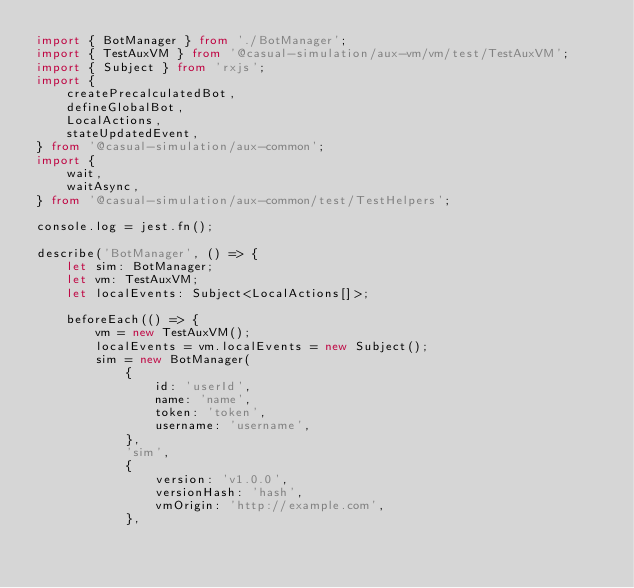Convert code to text. <code><loc_0><loc_0><loc_500><loc_500><_TypeScript_>import { BotManager } from './BotManager';
import { TestAuxVM } from '@casual-simulation/aux-vm/vm/test/TestAuxVM';
import { Subject } from 'rxjs';
import {
    createPrecalculatedBot,
    defineGlobalBot,
    LocalActions,
    stateUpdatedEvent,
} from '@casual-simulation/aux-common';
import {
    wait,
    waitAsync,
} from '@casual-simulation/aux-common/test/TestHelpers';

console.log = jest.fn();

describe('BotManager', () => {
    let sim: BotManager;
    let vm: TestAuxVM;
    let localEvents: Subject<LocalActions[]>;

    beforeEach(() => {
        vm = new TestAuxVM();
        localEvents = vm.localEvents = new Subject();
        sim = new BotManager(
            {
                id: 'userId',
                name: 'name',
                token: 'token',
                username: 'username',
            },
            'sim',
            {
                version: 'v1.0.0',
                versionHash: 'hash',
                vmOrigin: 'http://example.com',
            },</code> 